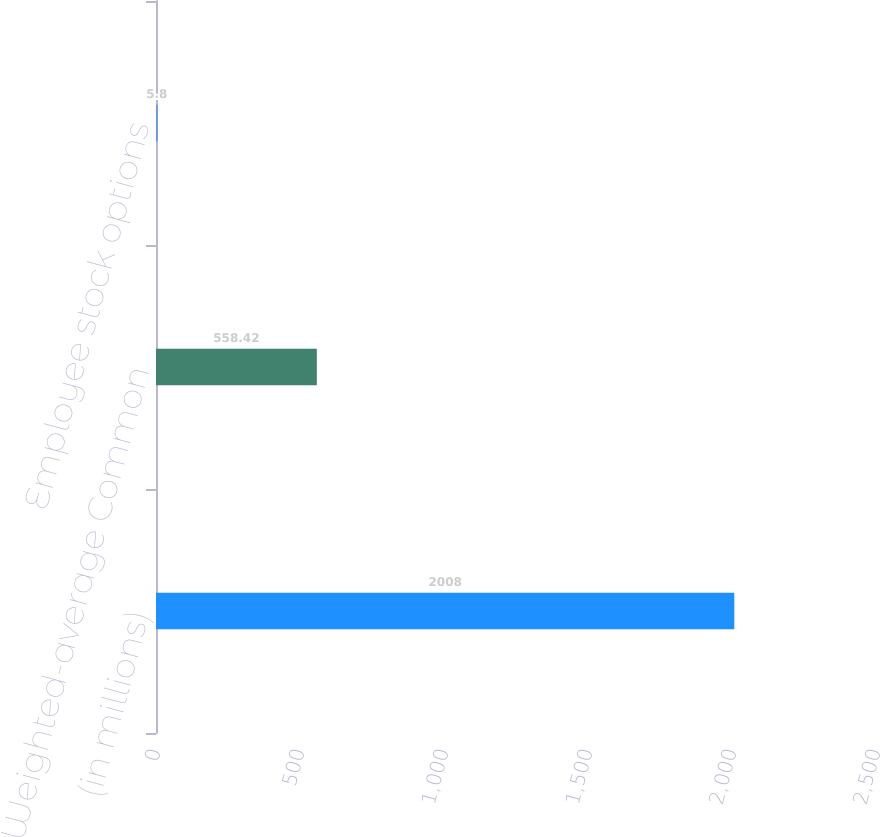Convert chart to OTSL. <chart><loc_0><loc_0><loc_500><loc_500><bar_chart><fcel>(in millions)<fcel>Weighted-average Common<fcel>Employee stock options<nl><fcel>2008<fcel>558.42<fcel>5.8<nl></chart> 